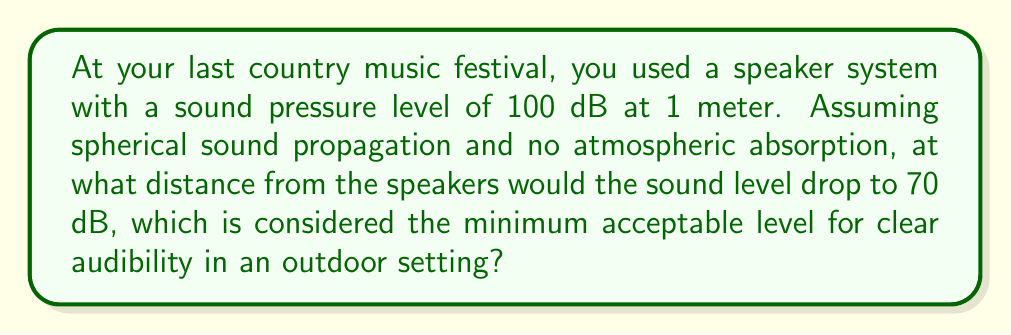Solve this math problem. To solve this problem, we'll use the inverse square law for sound propagation in free field conditions. The steps are as follows:

1) The inverse square law for sound propagation states that sound intensity decreases proportionally to the square of the distance from the source. The formula for sound level (L) at a distance r is:

   $$ L = L_1 - 20 \log_{10}(\frac{r}{r_1}) $$

   Where $L_1$ is the sound level at reference distance $r_1$.

2) In this case:
   $L_1 = 100$ dB (at 1 meter)
   $r_1 = 1$ meter
   $L = 70$ dB (the target sound level)
   We need to find $r$.

3) Plugging these values into the equation:

   $$ 70 = 100 - 20 \log_{10}(\frac{r}{1}) $$

4) Simplify:
   $$ -30 = -20 \log_{10}(r) $$

5) Divide both sides by -20:
   $$ 1.5 = \log_{10}(r) $$

6) Take $10$ to the power of both sides:
   $$ 10^{1.5} = r $$

7) Calculate:
   $$ r \approx 31.62 \text{ meters} $$

Therefore, the sound level would drop to 70 dB at approximately 31.62 meters from the speakers.
Answer: 31.62 meters 